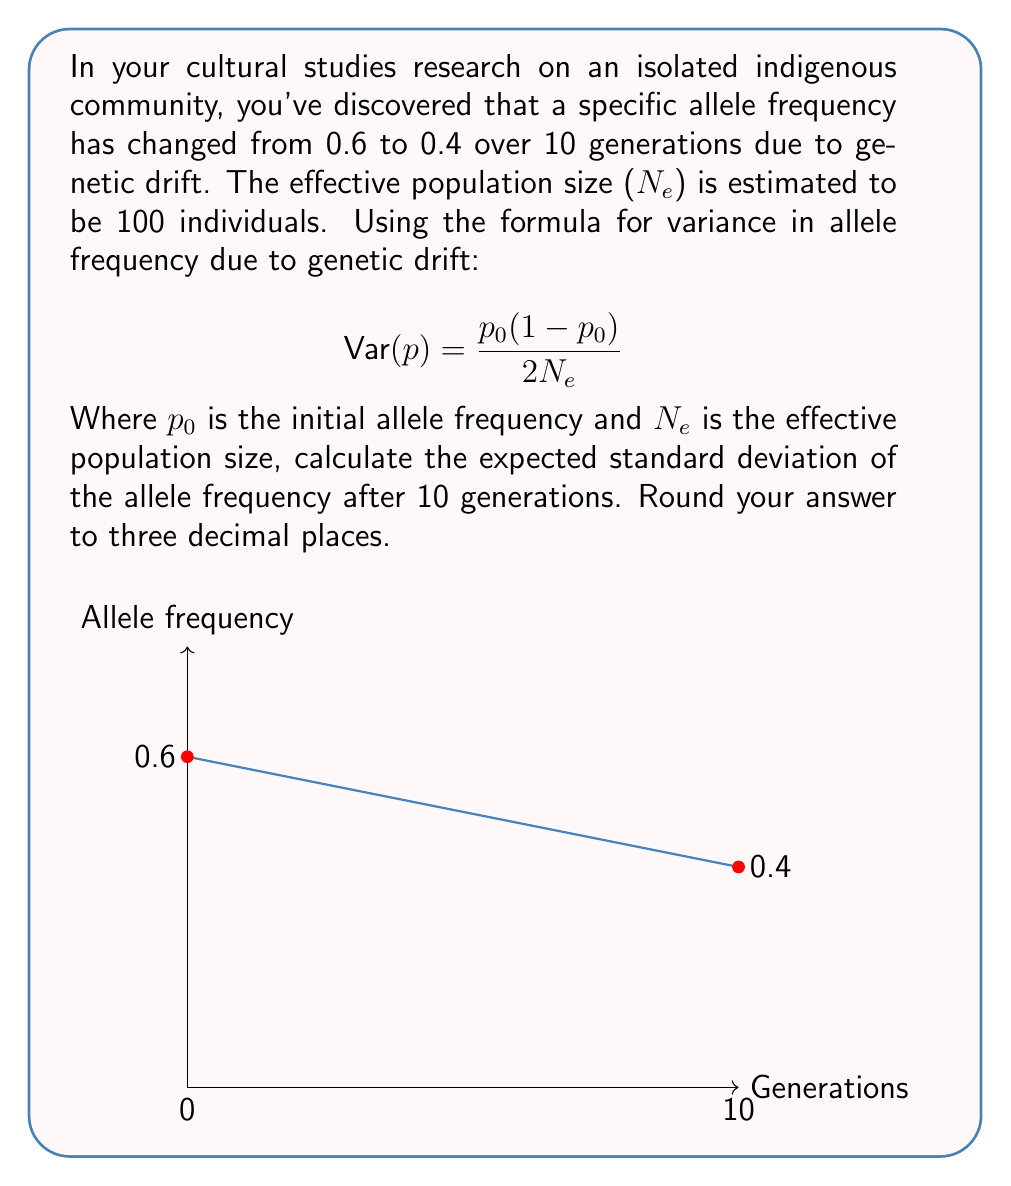Can you answer this question? Let's approach this step-by-step:

1) We're given:
   - Initial allele frequency $p_0 = 0.6$
   - Effective population size $N_e = 100$
   - Number of generations $t = 10$

2) The formula for variance in allele frequency per generation is:

   $$ \text{Var}(p) = \frac{p_0(1-p_0)}{2N_e} $$

3) Let's calculate this:

   $$ \text{Var}(p) = \frac{0.6(1-0.6)}{2(100)} = \frac{0.6(0.4)}{200} = \frac{0.24}{200} = 0.0012 $$

4) This is the variance per generation. To get the variance after 10 generations, we multiply by 10:

   $$ \text{Var}(p_{10}) = 10 * 0.0012 = 0.012 $$

5) The standard deviation is the square root of the variance:

   $$ \text{SD}(p_{10}) = \sqrt{0.012} \approx 0.1095 $$

6) Rounding to three decimal places:

   $$ \text{SD}(p_{10}) \approx 0.110 $$
Answer: 0.110 